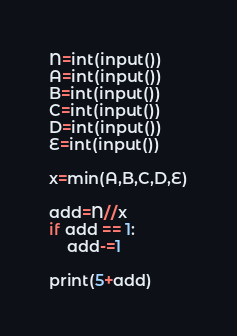<code> <loc_0><loc_0><loc_500><loc_500><_Python_>N=int(input())
A=int(input())
B=int(input())
C=int(input())
D=int(input())
E=int(input())

x=min(A,B,C,D,E)

add=N//x
if add == 1:
    add-=1

print(5+add)</code> 